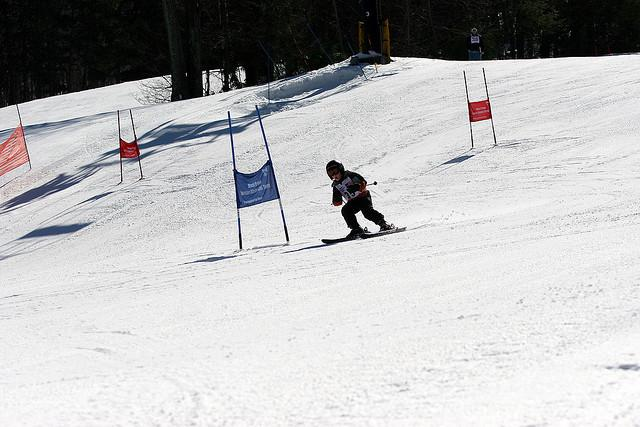What is the boy doing?

Choices:
A) stretching
B) running
C) descending
D) ascending descending 